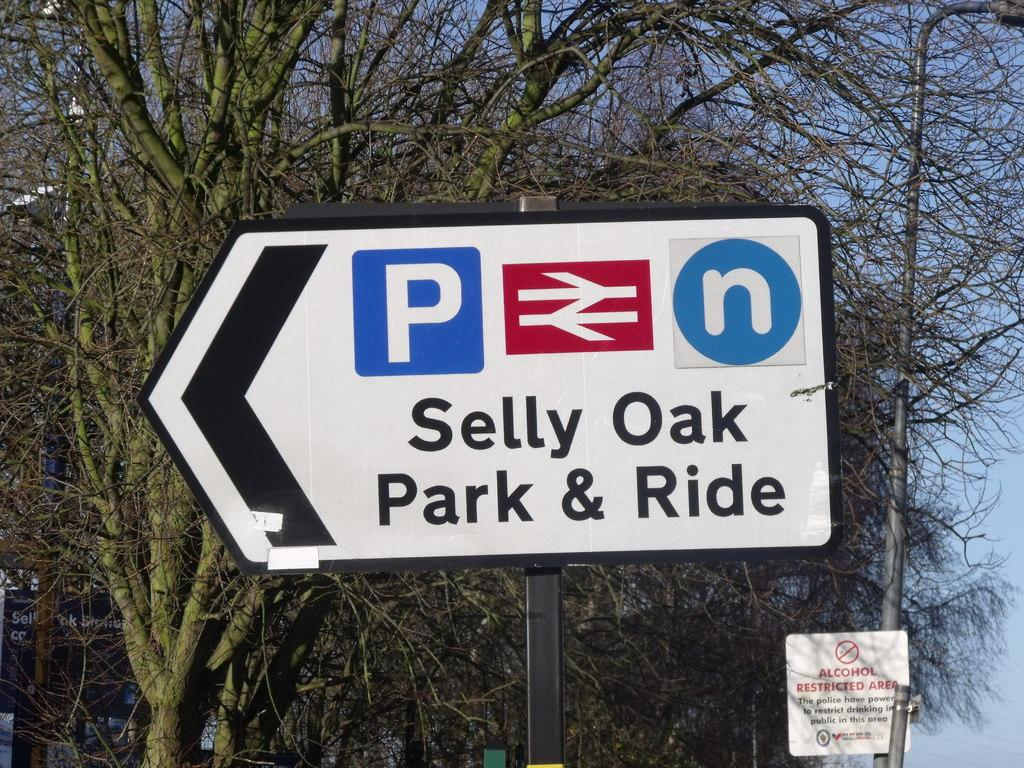Provide a one-sentence caption for the provided image. Selly Oak park and ride is to the left. 